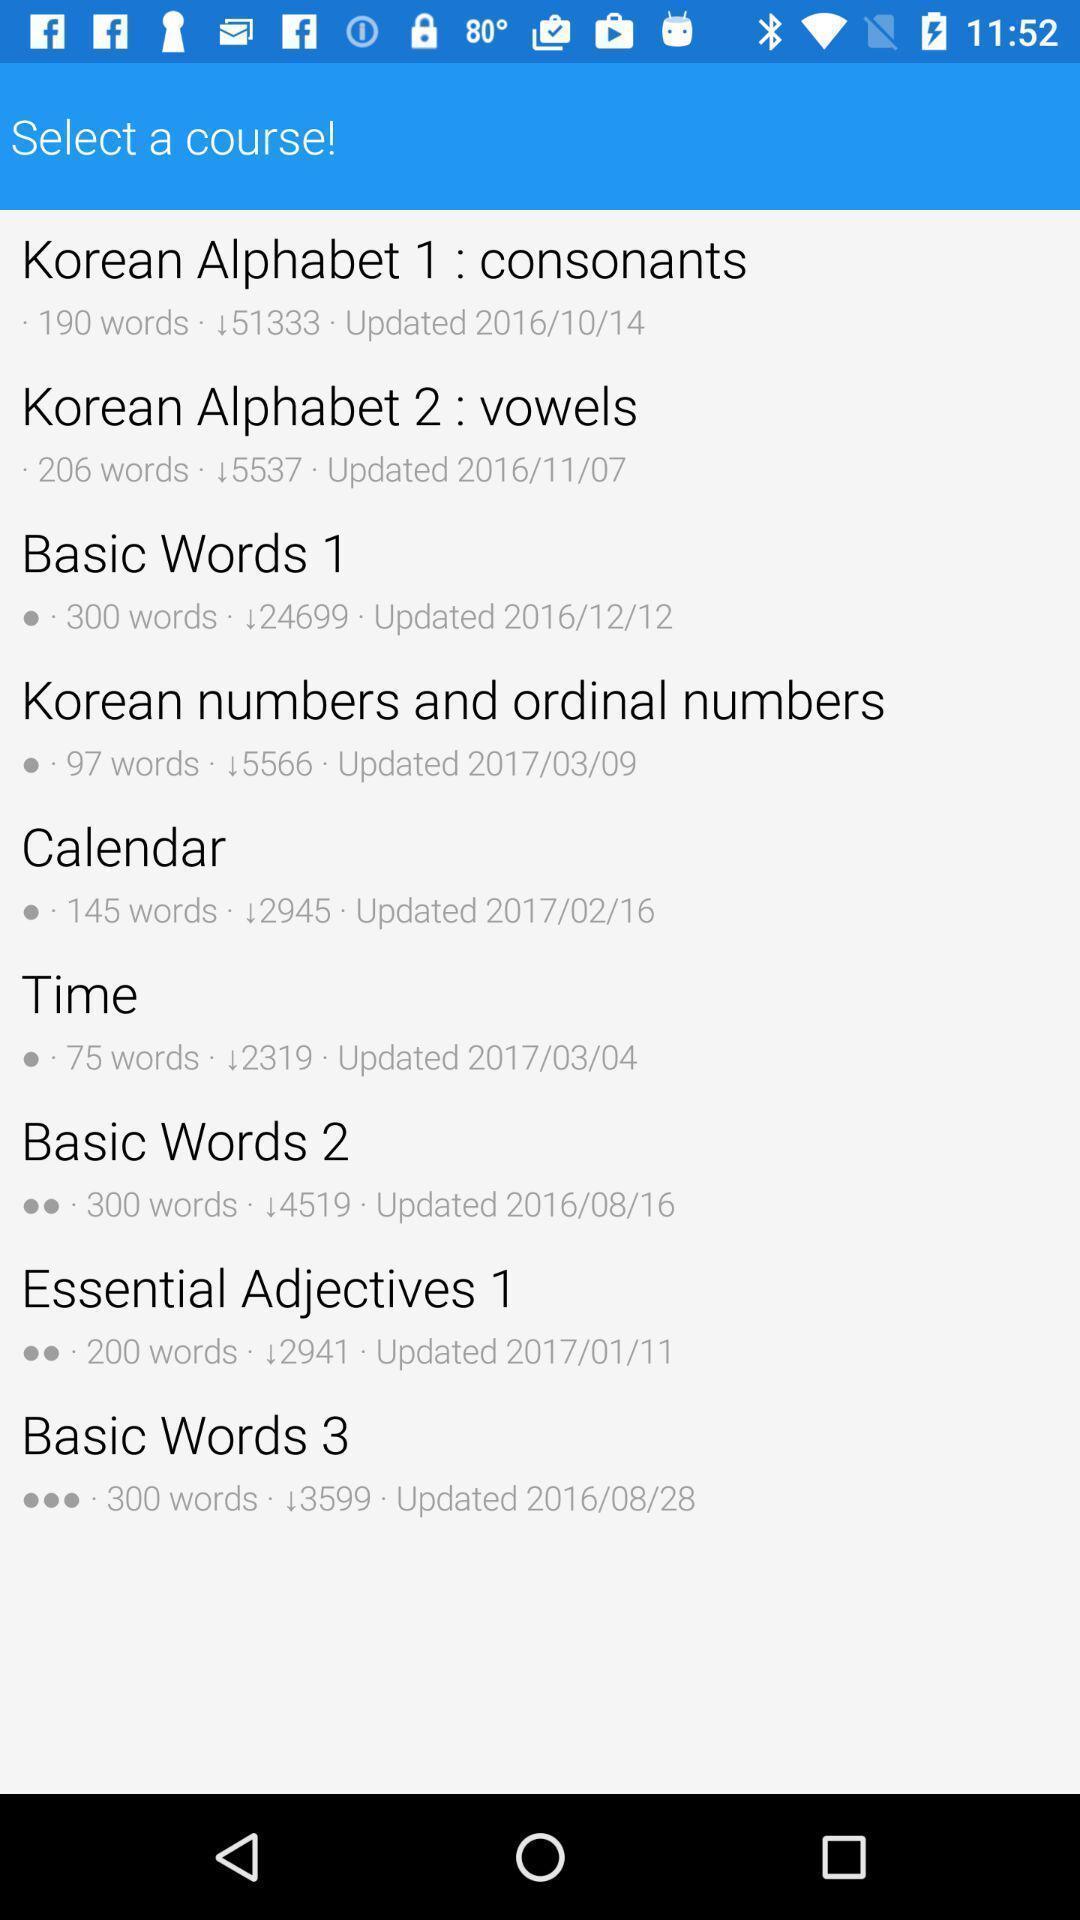Tell me what you see in this picture. Page showing variety of courses. 